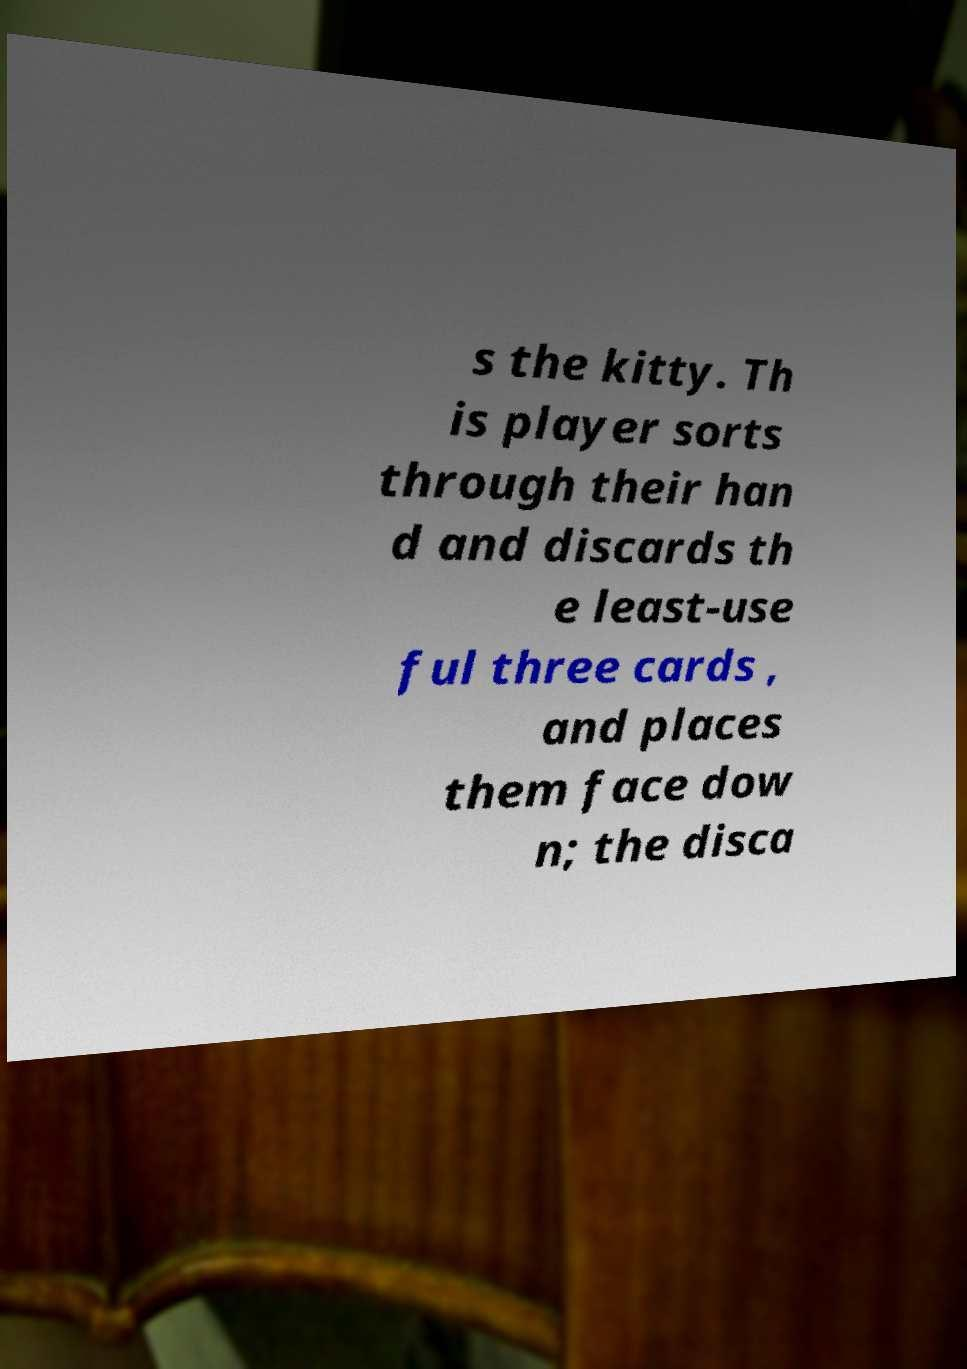I need the written content from this picture converted into text. Can you do that? s the kitty. Th is player sorts through their han d and discards th e least-use ful three cards , and places them face dow n; the disca 